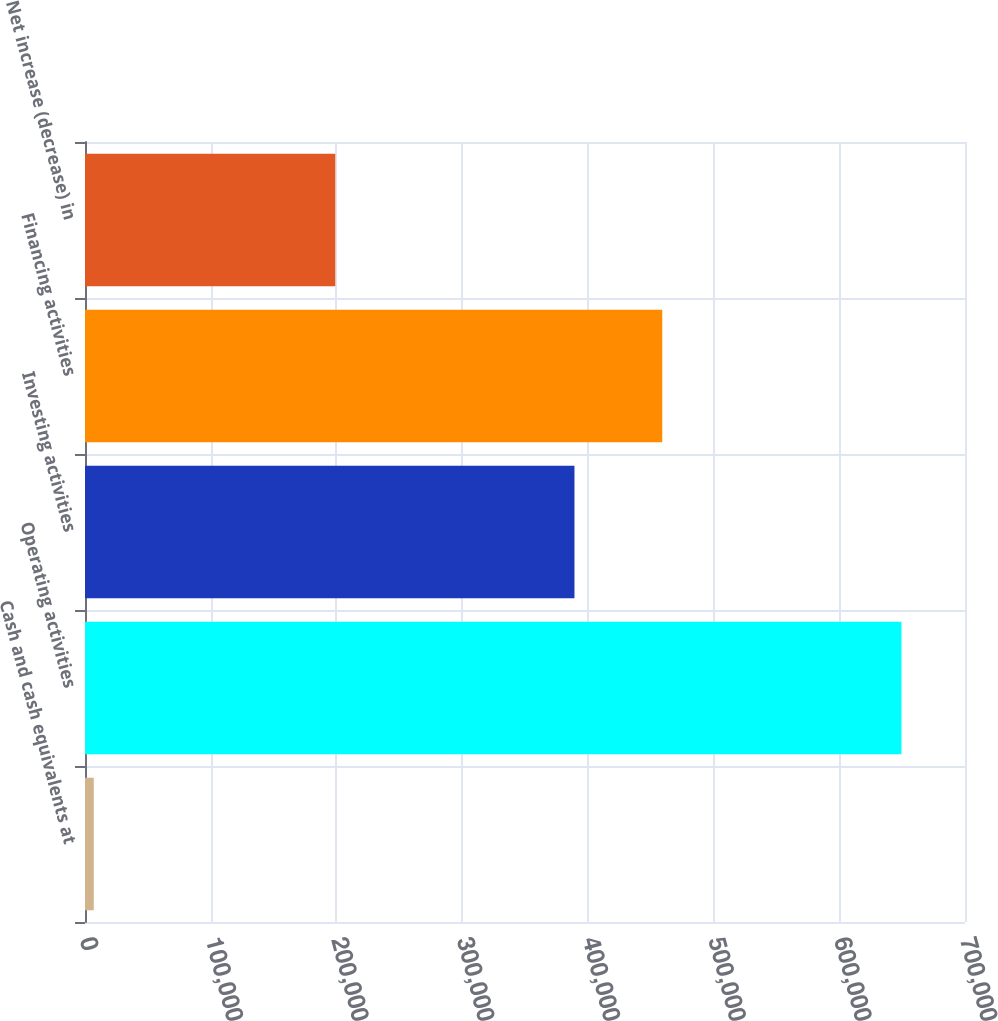Convert chart to OTSL. <chart><loc_0><loc_0><loc_500><loc_500><bar_chart><fcel>Cash and cash equivalents at<fcel>Operating activities<fcel>Investing activities<fcel>Financing activities<fcel>Net increase (decrease) in<nl><fcel>6974<fcel>649458<fcel>389344<fcel>459170<fcel>199056<nl></chart> 